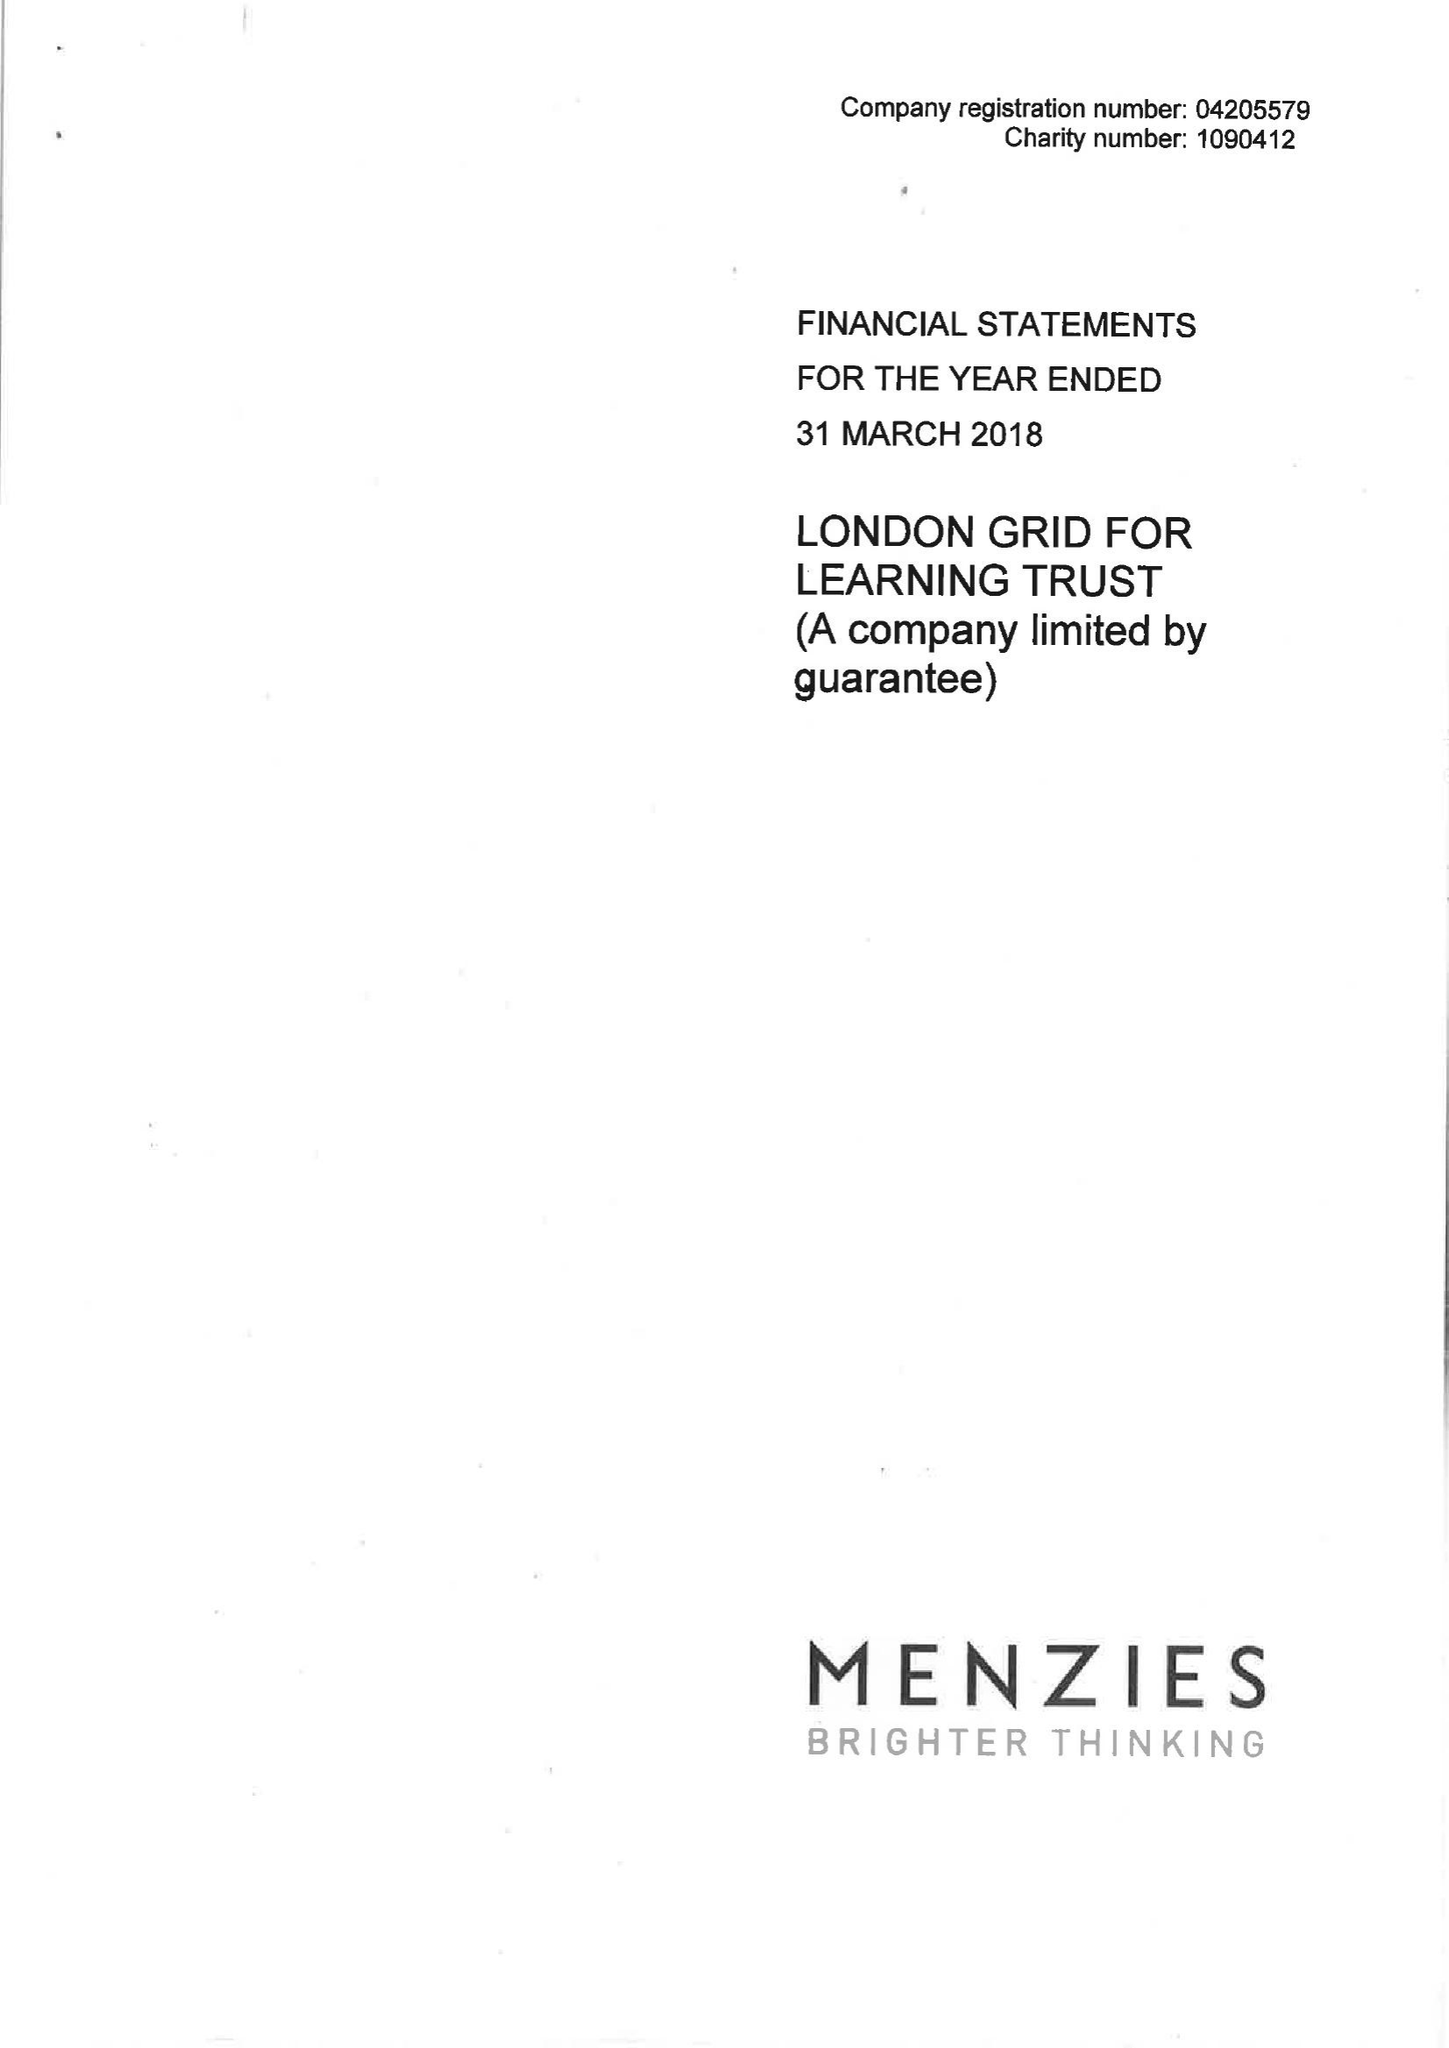What is the value for the report_date?
Answer the question using a single word or phrase. 2018-03-31 